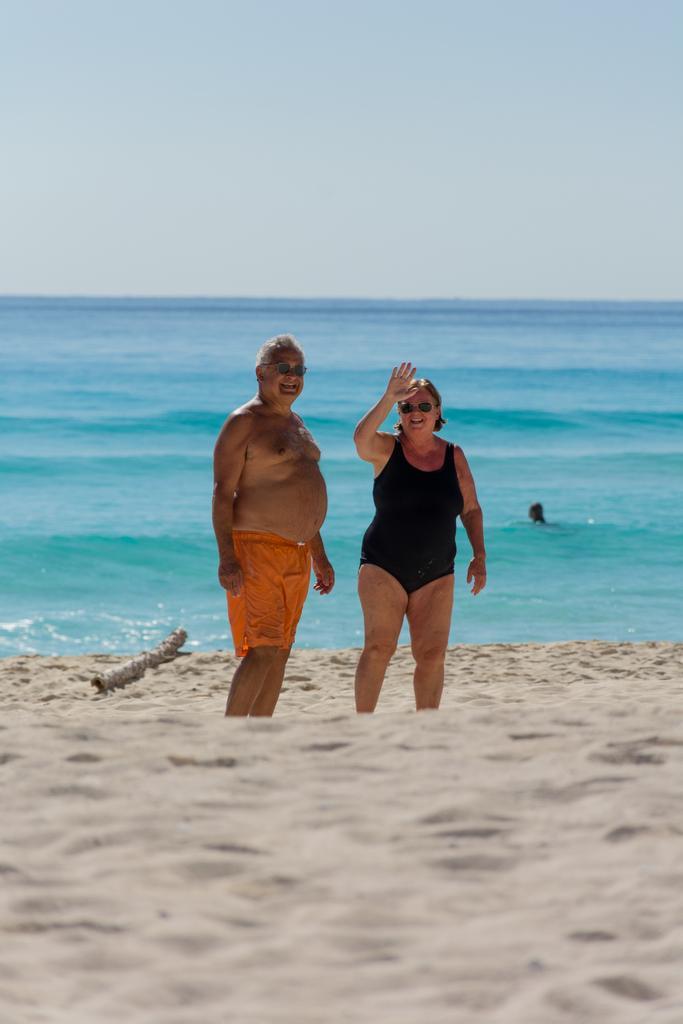In one or two sentences, can you explain what this image depicts? In this image we can see few people in the image. We can see the beach in the image. There is a wooden object on the ground at the left side of the image. We can see the sky in the image. There is a sea in the image. A person is in the water at the right side of the image. 